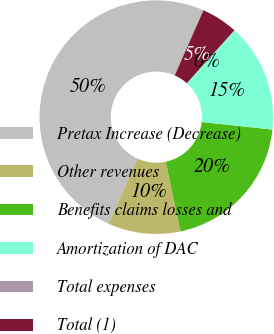Convert chart to OTSL. <chart><loc_0><loc_0><loc_500><loc_500><pie_chart><fcel>Pretax Increase (Decrease)<fcel>Other revenues<fcel>Benefits claims losses and<fcel>Amortization of DAC<fcel>Total expenses<fcel>Total (1)<nl><fcel>49.9%<fcel>10.02%<fcel>19.99%<fcel>15.0%<fcel>0.05%<fcel>5.03%<nl></chart> 